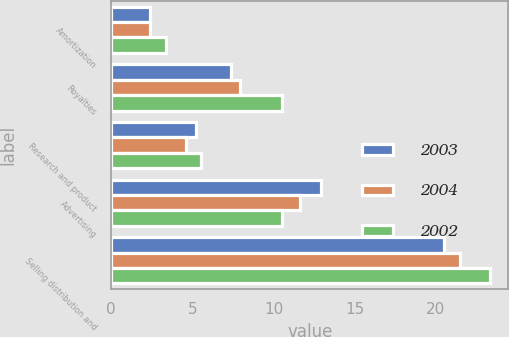<chart> <loc_0><loc_0><loc_500><loc_500><stacked_bar_chart><ecel><fcel>Amortization<fcel>Royalties<fcel>Research and product<fcel>Advertising<fcel>Selling distribution and<nl><fcel>2003<fcel>2.4<fcel>7.4<fcel>5.2<fcel>12.9<fcel>20.5<nl><fcel>2004<fcel>2.4<fcel>7.9<fcel>4.6<fcel>11.6<fcel>21.5<nl><fcel>2002<fcel>3.4<fcel>10.5<fcel>5.5<fcel>10.5<fcel>23.3<nl></chart> 